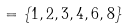<formula> <loc_0><loc_0><loc_500><loc_500>= \{ 1 , 2 , 3 , 4 , 6 , 8 \}</formula> 